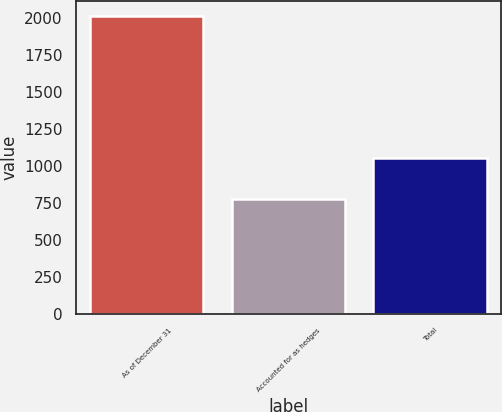Convert chart. <chart><loc_0><loc_0><loc_500><loc_500><bar_chart><fcel>As of December 31<fcel>Accounted for as hedges<fcel>Total<nl><fcel>2015<fcel>778<fcel>1058<nl></chart> 